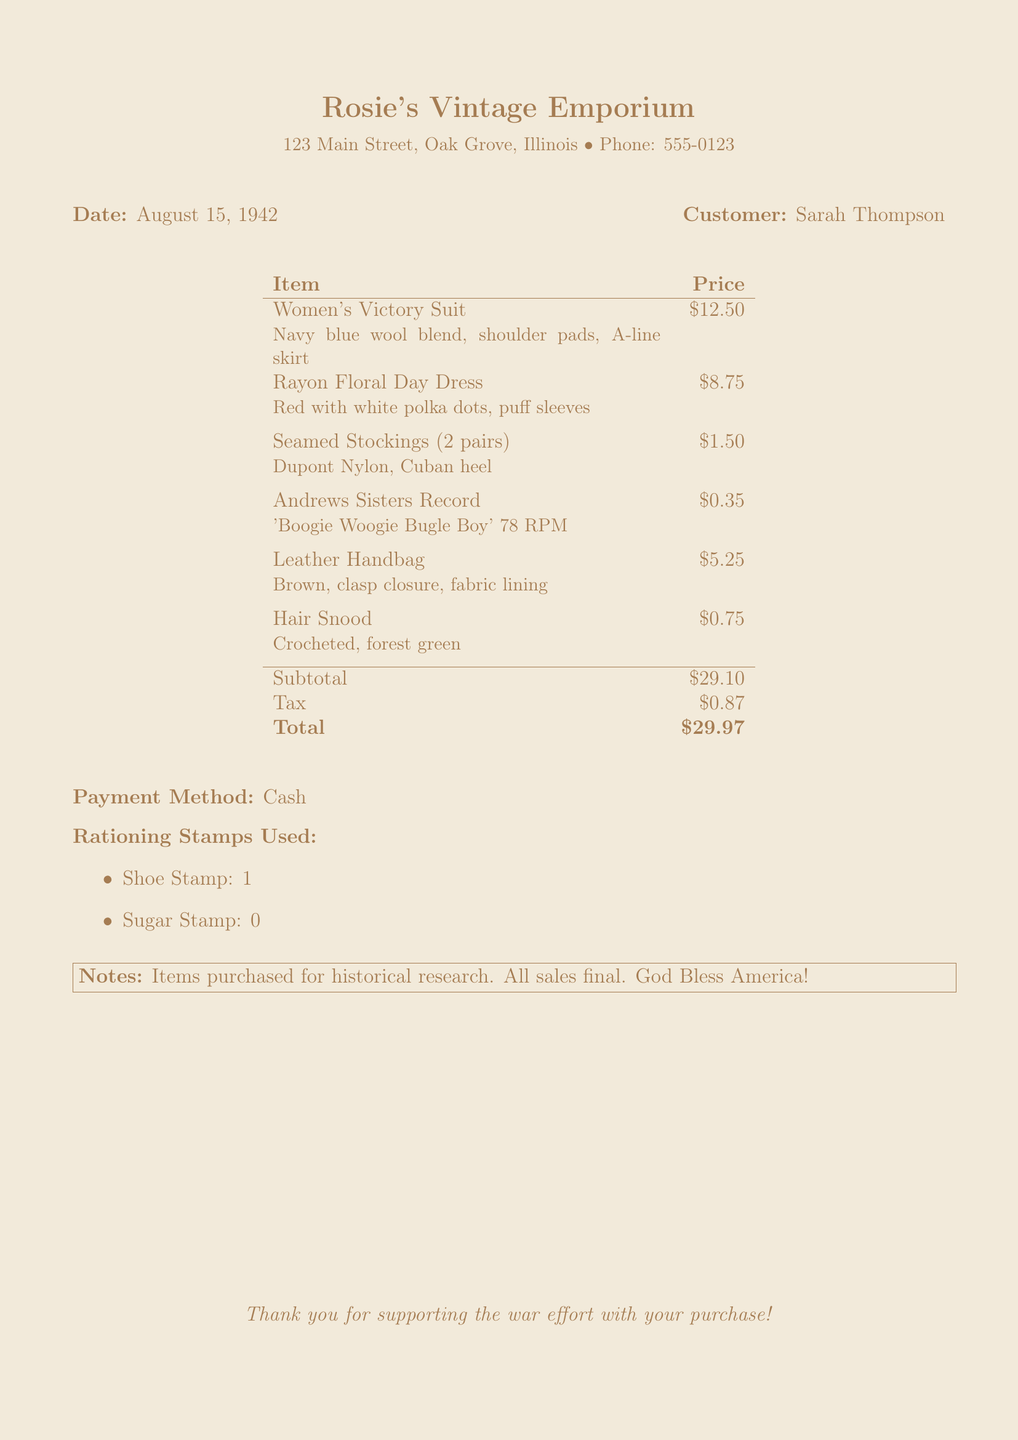What is the store name? The store name is located at the top of the receipt, which details where the purchase was made.
Answer: Rosie's Vintage Emporium What is the date of the transaction? The date is provided near the top of the document, specifying when the purchase occurred.
Answer: August 15, 1942 Who is the customer? The customer's name is mentioned next to the date on the receipt, indicating who made the purchase.
Answer: Sarah Thompson What is the total amount spent? The total amount is shown at the bottom of the price table, representing the overall cost of the items purchased.
Answer: $29.97 How much was the tax? The tax amount is listed as a separate line item just before the total, showing additional costs added to the subtotal.
Answer: $0.87 What was the price of the Women's Victory Suit? The individual item prices are clearly stated next to each item, indicating how much each costs.
Answer: $12.50 How many pairs of stockings were purchased? The document explains the number of pairs of stockings as part of the item description in the list.
Answer: 2 pairs What payment method was used? The payment method is indicated in a specific line towards the end of the receipt, showing how the transaction was completed.
Answer: Cash How many shoe stamps were used? The document lists the rationing stamps used, detailing how many were applied to the purchase.
Answer: 1 